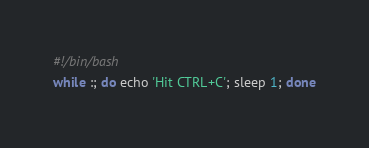<code> <loc_0><loc_0><loc_500><loc_500><_Bash_>#!/bin/bash
while :; do echo 'Hit CTRL+C'; sleep 1; done</code> 